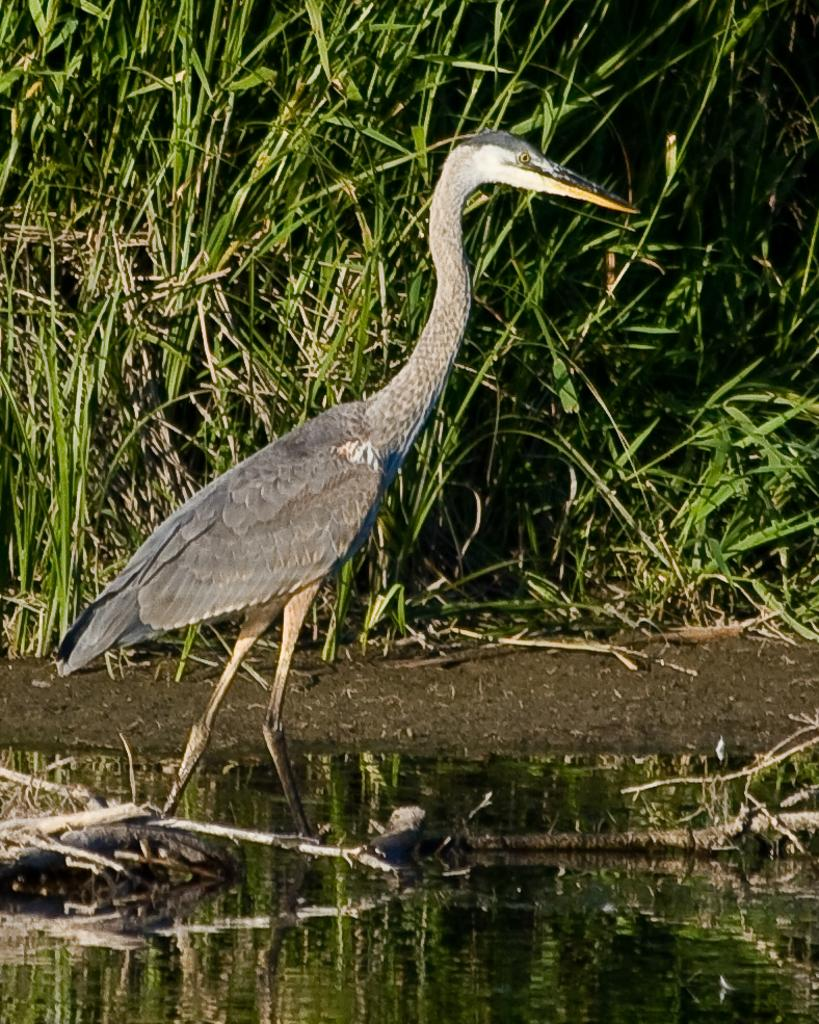What type of animal can be seen in the image? There is a bird in the image. What is the primary element in which the bird is situated? The bird is situated in water. What objects are present in the image? There are wooden sticks and plants visible in the image. What part of the natural environment is visible in the image? The ground is visible in the image. What can be observed in the water? There is a reflection in the water. What type of jeans is the bird wearing in the image? There is no mention of jeans or any clothing in the image; the bird is not wearing any clothing. 